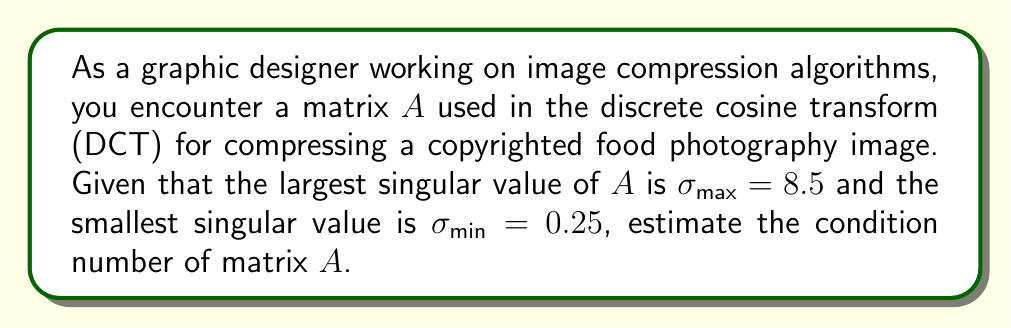Help me with this question. To estimate the condition number of matrix $A$, we'll follow these steps:

1) The condition number $\kappa(A)$ of a matrix $A$ is defined as:

   $$\kappa(A) = \frac{\sigma_{\text{max}}}{\sigma_{\text{min}}}$$

   where $\sigma_{\text{max}}$ is the largest singular value and $\sigma_{\text{min}}$ is the smallest singular value of $A$.

2) We are given:
   $\sigma_{\text{max}} = 8.5$
   $\sigma_{\text{min}} = 0.25$

3) Substituting these values into the formula:

   $$\kappa(A) = \frac{8.5}{0.25}$$

4) Perform the division:

   $$\kappa(A) = 34$$

The condition number provides insight into how sensitive the image compression algorithm is to small changes in the input data. A higher condition number indicates that the matrix is more ill-conditioned, which could lead to larger errors in the compressed image.
Answer: $34$ 